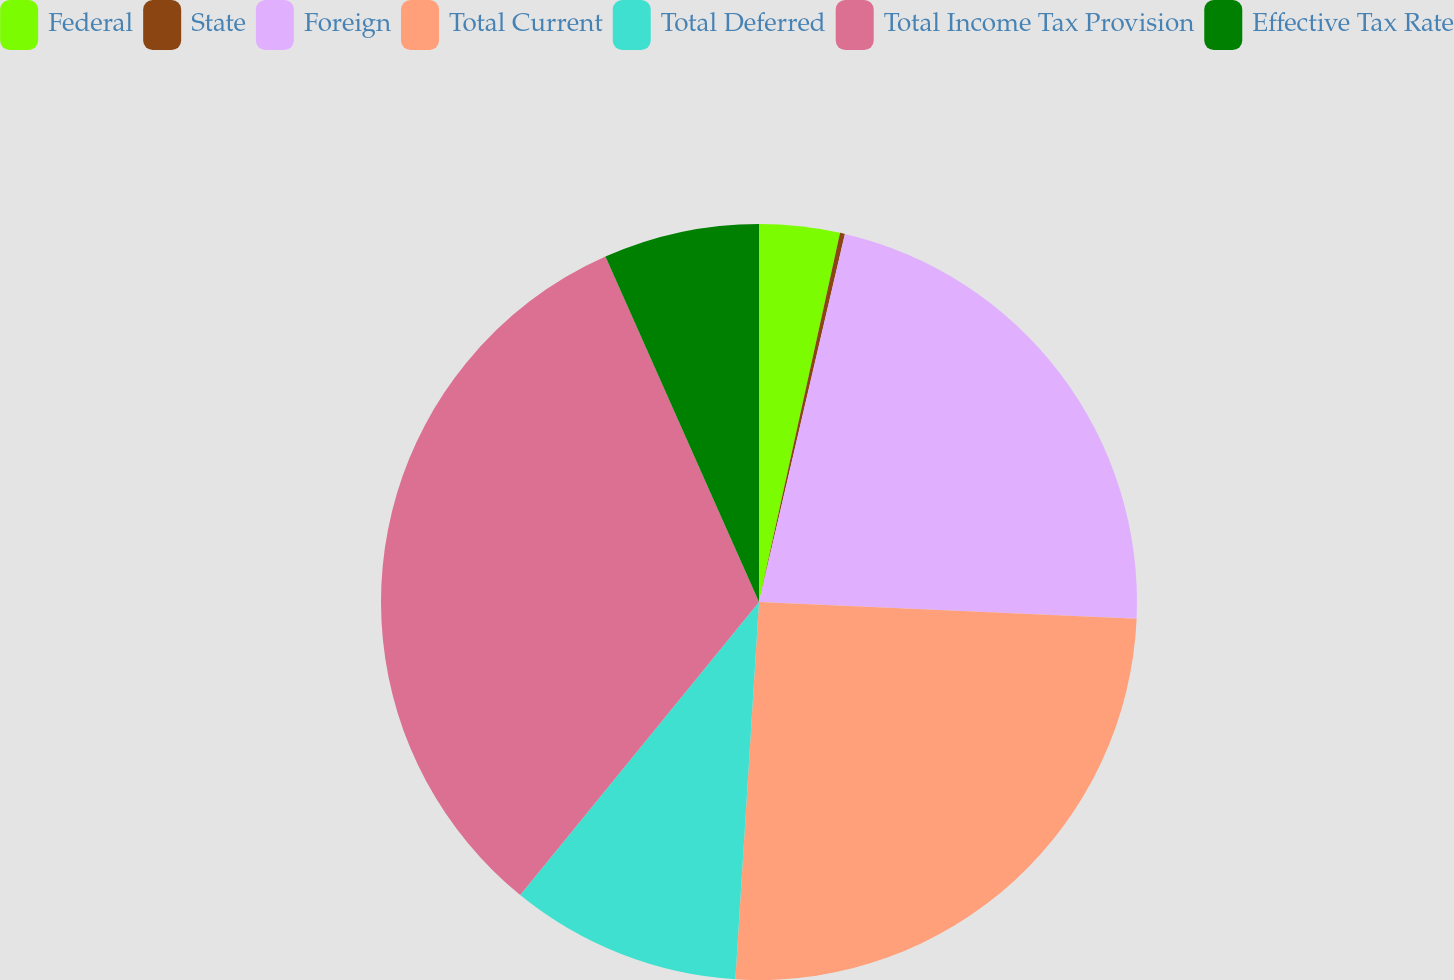Convert chart to OTSL. <chart><loc_0><loc_0><loc_500><loc_500><pie_chart><fcel>Federal<fcel>State<fcel>Foreign<fcel>Total Current<fcel>Total Deferred<fcel>Total Income Tax Provision<fcel>Effective Tax Rate<nl><fcel>3.44%<fcel>0.21%<fcel>22.06%<fcel>25.29%<fcel>9.89%<fcel>32.46%<fcel>6.66%<nl></chart> 